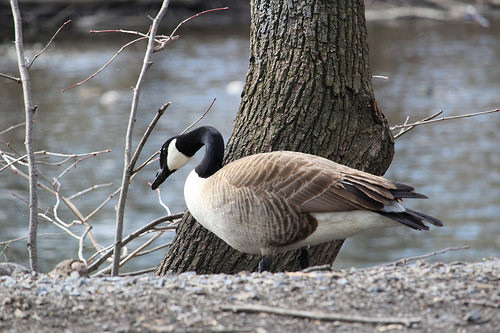<image>
Is the bird on the tree? No. The bird is not positioned on the tree. They may be near each other, but the bird is not supported by or resting on top of the tree. 